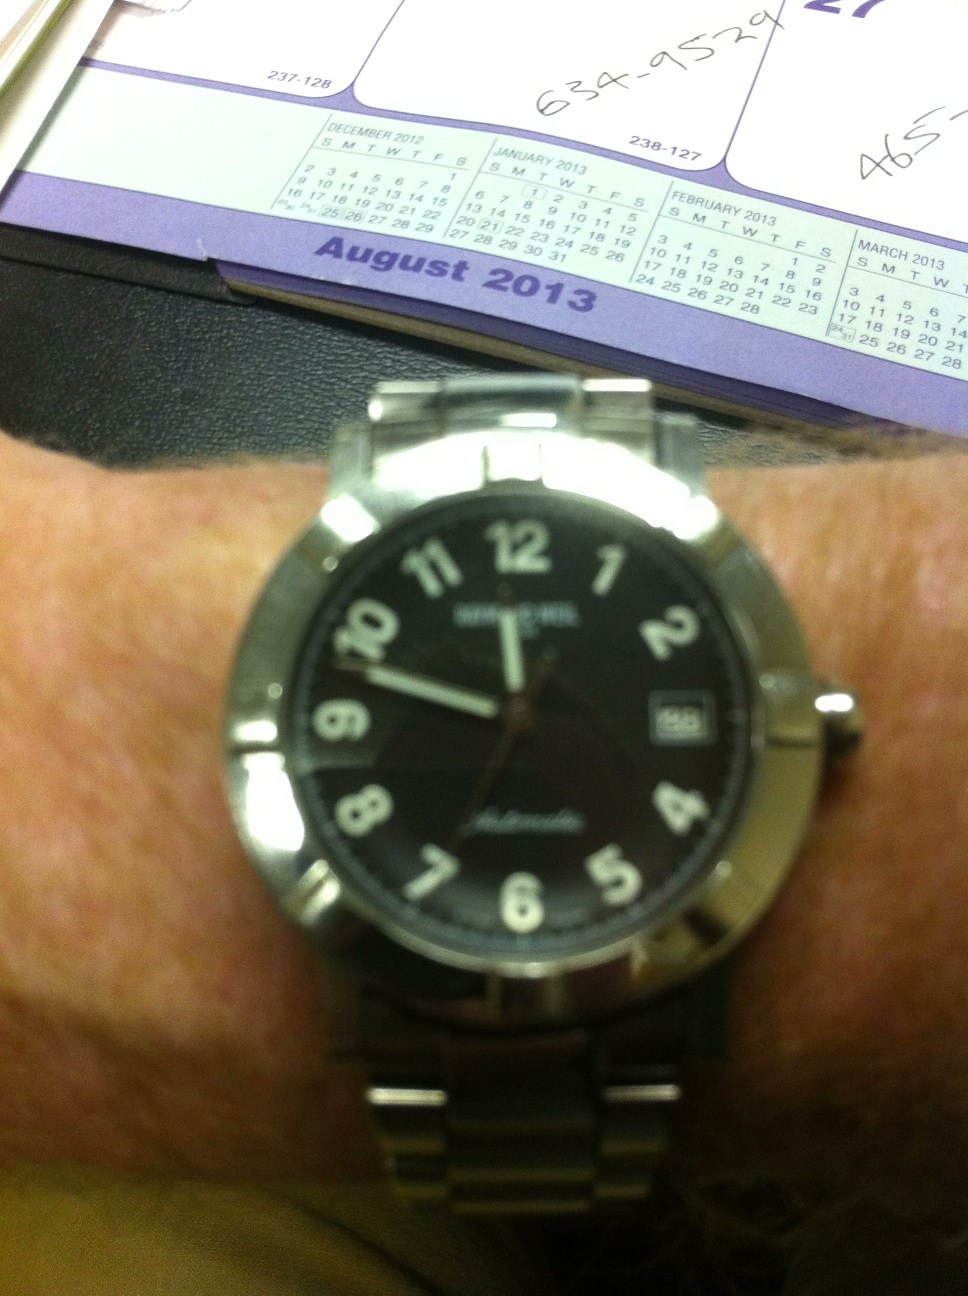Can you please tell me the time? from Vizwiz The time displayed on the watch in the image is 11:48. This watch has a classic design with distinct, easy-to-read numbers and a date feature, which shows '25', indicating it's the 25th of the month. 